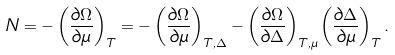Convert formula to latex. <formula><loc_0><loc_0><loc_500><loc_500>N & = - \left ( \frac { \partial \Omega } { \partial \mu } \right ) _ { T } = - \left ( \frac { \partial \Omega } { \partial \mu } \right ) _ { T , \Delta } - \left ( \frac { \partial \Omega } { \partial \Delta } \right ) _ { T , \mu } \left ( \frac { \partial \Delta } { \partial \mu } \right ) _ { T } .</formula> 